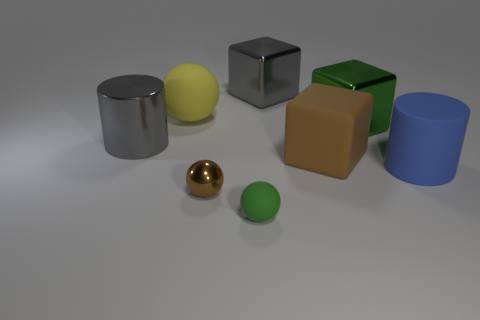Add 1 brown metal objects. How many objects exist? 9 Subtract all brown balls. How many balls are left? 2 Subtract all balls. How many objects are left? 5 Subtract 2 blocks. How many blocks are left? 1 Subtract 0 yellow cubes. How many objects are left? 8 Subtract all green blocks. Subtract all green cylinders. How many blocks are left? 2 Subtract all purple cylinders. How many green cubes are left? 1 Subtract all brown objects. Subtract all small green rubber things. How many objects are left? 5 Add 6 green shiny things. How many green shiny things are left? 7 Add 6 large spheres. How many large spheres exist? 7 